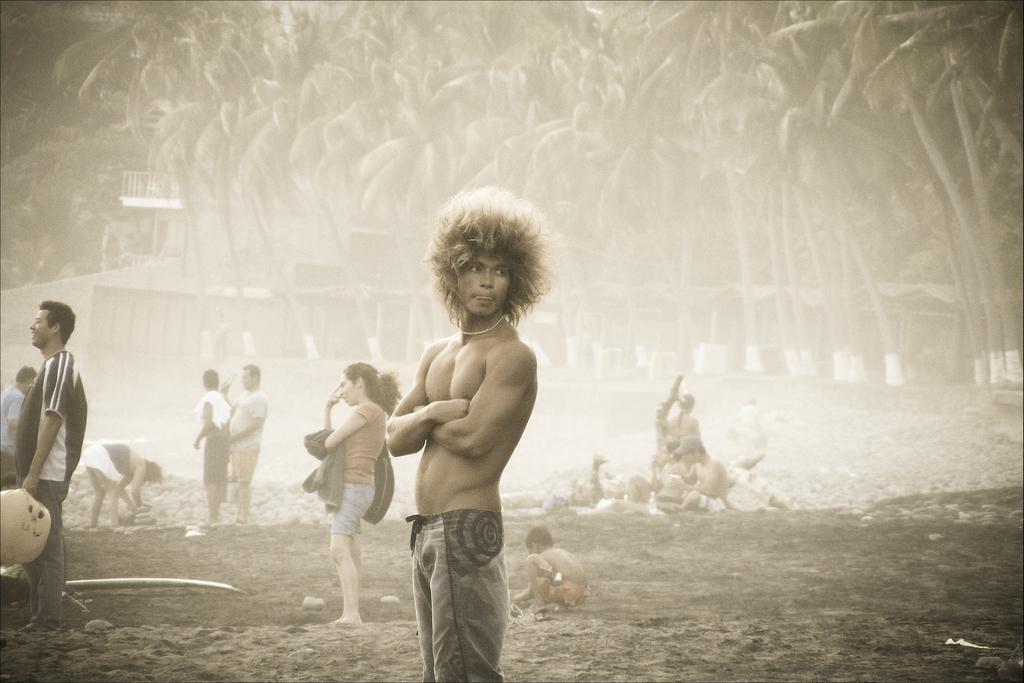Who or what can be seen in the image? There are people in the image. What can be seen in the distance behind the people? There are trees and sheds in the background of the image. Where is the bucket located in the image? There is no bucket present in the image. What type of cannon is being used by the people in the image? There is no cannon present in the image. 